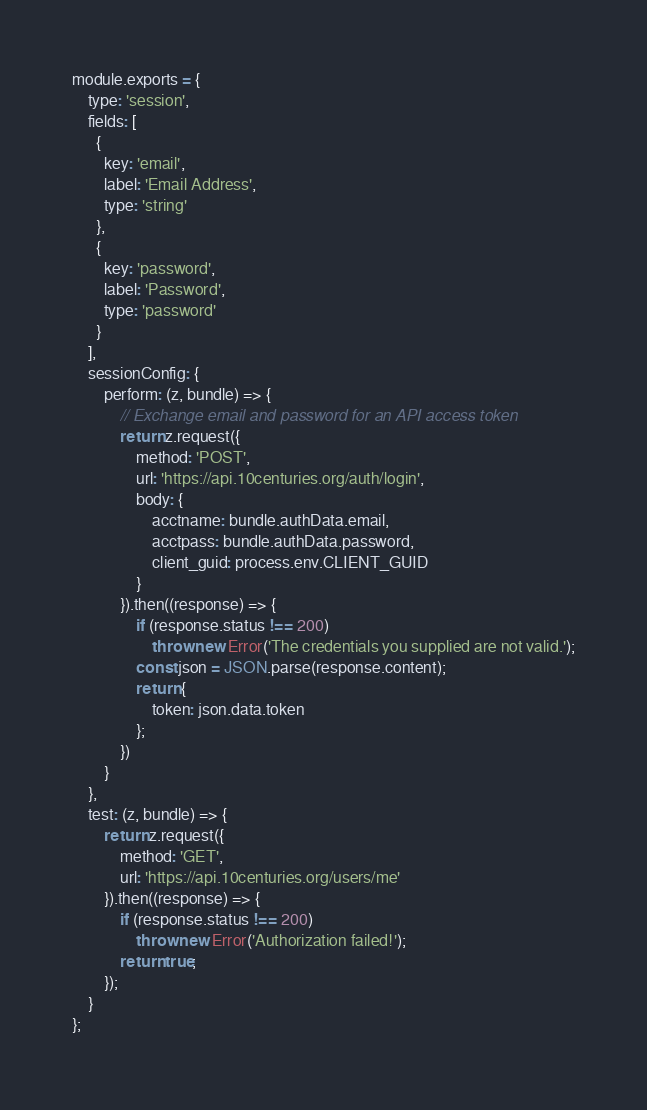Convert code to text. <code><loc_0><loc_0><loc_500><loc_500><_JavaScript_>module.exports = {
    type: 'session',
    fields: [
      {
        key: 'email',
        label: 'Email Address',
        type: 'string'       
      },
      {
        key: 'password',
        label: 'Password',
        type: 'password'       
      }
    ],
    sessionConfig: {
        perform: (z, bundle) => {
            // Exchange email and password for an API access token
            return z.request({
                method: 'POST',
                url: 'https://api.10centuries.org/auth/login',
                body: {
                    acctname: bundle.authData.email,
                    acctpass: bundle.authData.password,
                    client_guid: process.env.CLIENT_GUID
                }
            }).then((response) => {
                if (response.status !== 200)
                    throw new Error('The credentials you supplied are not valid.');
                const json = JSON.parse(response.content);
                return {
                    token: json.data.token
                };
            })
        }
    },
    test: (z, bundle) => {
        return z.request({
            method: 'GET',
            url: 'https://api.10centuries.org/users/me'
        }).then((response) => {
            if (response.status !== 200)
                throw new Error('Authorization failed!');
            return true;
        });         
    }
};</code> 